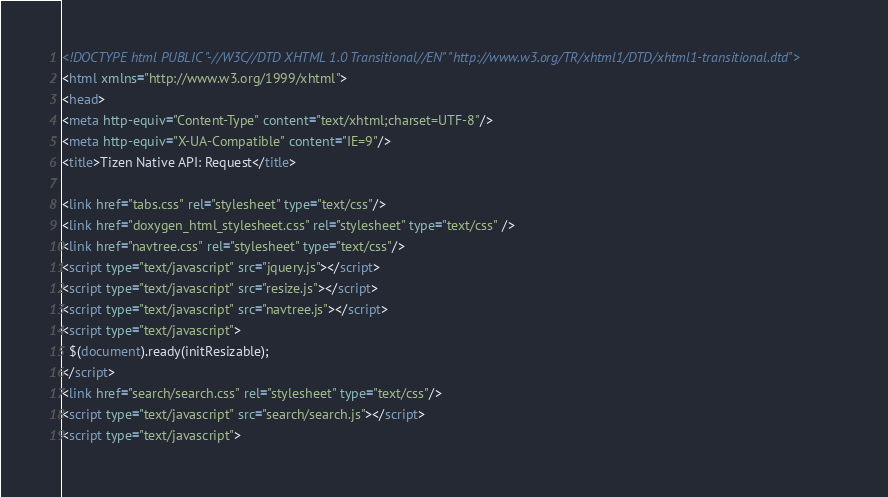Convert code to text. <code><loc_0><loc_0><loc_500><loc_500><_HTML_><!DOCTYPE html PUBLIC "-//W3C//DTD XHTML 1.0 Transitional//EN" "http://www.w3.org/TR/xhtml1/DTD/xhtml1-transitional.dtd">
<html xmlns="http://www.w3.org/1999/xhtml">
<head>
<meta http-equiv="Content-Type" content="text/xhtml;charset=UTF-8"/>
<meta http-equiv="X-UA-Compatible" content="IE=9"/>
<title>Tizen Native API: Request</title>

<link href="tabs.css" rel="stylesheet" type="text/css"/>
<link href="doxygen_html_stylesheet.css" rel="stylesheet" type="text/css" />
<link href="navtree.css" rel="stylesheet" type="text/css"/>
<script type="text/javascript" src="jquery.js"></script>
<script type="text/javascript" src="resize.js"></script>
<script type="text/javascript" src="navtree.js"></script>
<script type="text/javascript">
  $(document).ready(initResizable);
</script>
<link href="search/search.css" rel="stylesheet" type="text/css"/>
<script type="text/javascript" src="search/search.js"></script>
<script type="text/javascript"></code> 